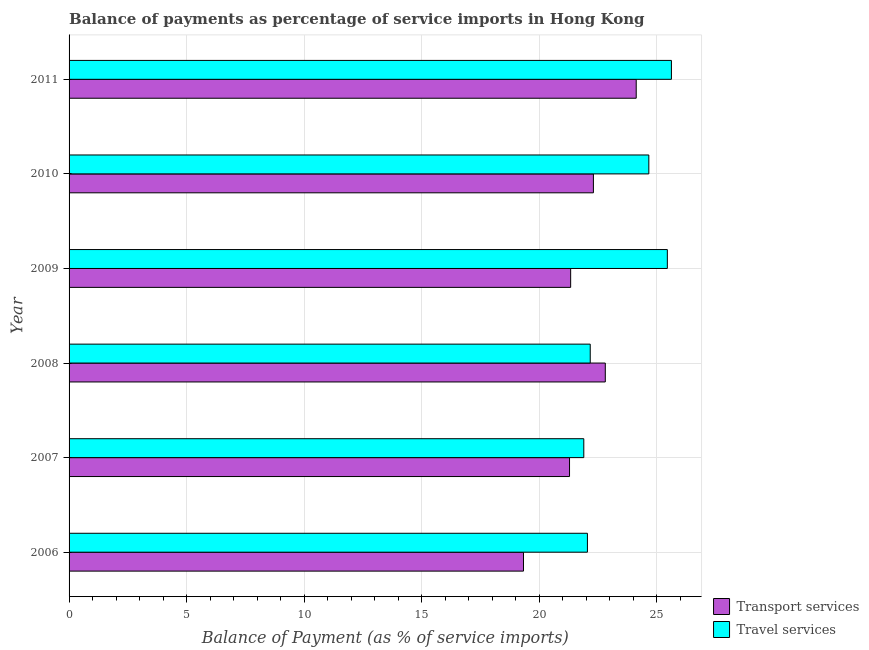How many different coloured bars are there?
Offer a very short reply. 2. Are the number of bars per tick equal to the number of legend labels?
Provide a succinct answer. Yes. Are the number of bars on each tick of the Y-axis equal?
Your answer should be very brief. Yes. In how many cases, is the number of bars for a given year not equal to the number of legend labels?
Offer a terse response. 0. What is the balance of payments of travel services in 2007?
Make the answer very short. 21.89. Across all years, what is the maximum balance of payments of travel services?
Make the answer very short. 25.62. Across all years, what is the minimum balance of payments of travel services?
Make the answer very short. 21.89. In which year was the balance of payments of transport services minimum?
Keep it short and to the point. 2006. What is the total balance of payments of travel services in the graph?
Your response must be concise. 141.81. What is the difference between the balance of payments of travel services in 2009 and that in 2010?
Your answer should be compact. 0.79. What is the difference between the balance of payments of transport services in 2009 and the balance of payments of travel services in 2006?
Your answer should be very brief. -0.71. What is the average balance of payments of travel services per year?
Offer a terse response. 23.64. In the year 2006, what is the difference between the balance of payments of travel services and balance of payments of transport services?
Offer a very short reply. 2.72. What is the ratio of the balance of payments of transport services in 2007 to that in 2011?
Your response must be concise. 0.88. Is the balance of payments of transport services in 2008 less than that in 2010?
Make the answer very short. No. Is the difference between the balance of payments of travel services in 2008 and 2009 greater than the difference between the balance of payments of transport services in 2008 and 2009?
Make the answer very short. No. What is the difference between the highest and the second highest balance of payments of transport services?
Keep it short and to the point. 1.31. What is the difference between the highest and the lowest balance of payments of travel services?
Ensure brevity in your answer.  3.73. In how many years, is the balance of payments of travel services greater than the average balance of payments of travel services taken over all years?
Offer a terse response. 3. Is the sum of the balance of payments of travel services in 2006 and 2007 greater than the maximum balance of payments of transport services across all years?
Your answer should be compact. Yes. What does the 2nd bar from the top in 2011 represents?
Offer a very short reply. Transport services. What does the 1st bar from the bottom in 2008 represents?
Give a very brief answer. Transport services. How many bars are there?
Provide a short and direct response. 12. Are all the bars in the graph horizontal?
Your response must be concise. Yes. Are the values on the major ticks of X-axis written in scientific E-notation?
Ensure brevity in your answer.  No. Does the graph contain any zero values?
Offer a terse response. No. Where does the legend appear in the graph?
Give a very brief answer. Bottom right. What is the title of the graph?
Offer a terse response. Balance of payments as percentage of service imports in Hong Kong. What is the label or title of the X-axis?
Ensure brevity in your answer.  Balance of Payment (as % of service imports). What is the Balance of Payment (as % of service imports) of Transport services in 2006?
Your answer should be very brief. 19.32. What is the Balance of Payment (as % of service imports) in Travel services in 2006?
Your answer should be compact. 22.04. What is the Balance of Payment (as % of service imports) in Transport services in 2007?
Give a very brief answer. 21.28. What is the Balance of Payment (as % of service imports) of Travel services in 2007?
Offer a terse response. 21.89. What is the Balance of Payment (as % of service imports) in Transport services in 2008?
Provide a short and direct response. 22.8. What is the Balance of Payment (as % of service imports) of Travel services in 2008?
Your response must be concise. 22.16. What is the Balance of Payment (as % of service imports) in Transport services in 2009?
Your response must be concise. 21.33. What is the Balance of Payment (as % of service imports) of Travel services in 2009?
Offer a very short reply. 25.44. What is the Balance of Payment (as % of service imports) of Transport services in 2010?
Make the answer very short. 22.3. What is the Balance of Payment (as % of service imports) of Travel services in 2010?
Offer a terse response. 24.66. What is the Balance of Payment (as % of service imports) of Transport services in 2011?
Offer a very short reply. 24.12. What is the Balance of Payment (as % of service imports) in Travel services in 2011?
Keep it short and to the point. 25.62. Across all years, what is the maximum Balance of Payment (as % of service imports) in Transport services?
Provide a short and direct response. 24.12. Across all years, what is the maximum Balance of Payment (as % of service imports) in Travel services?
Offer a very short reply. 25.62. Across all years, what is the minimum Balance of Payment (as % of service imports) in Transport services?
Your response must be concise. 19.32. Across all years, what is the minimum Balance of Payment (as % of service imports) of Travel services?
Your answer should be very brief. 21.89. What is the total Balance of Payment (as % of service imports) of Transport services in the graph?
Keep it short and to the point. 131.16. What is the total Balance of Payment (as % of service imports) in Travel services in the graph?
Your answer should be very brief. 141.81. What is the difference between the Balance of Payment (as % of service imports) in Transport services in 2006 and that in 2007?
Offer a terse response. -1.96. What is the difference between the Balance of Payment (as % of service imports) in Travel services in 2006 and that in 2007?
Your answer should be very brief. 0.15. What is the difference between the Balance of Payment (as % of service imports) in Transport services in 2006 and that in 2008?
Make the answer very short. -3.48. What is the difference between the Balance of Payment (as % of service imports) of Travel services in 2006 and that in 2008?
Ensure brevity in your answer.  -0.12. What is the difference between the Balance of Payment (as % of service imports) in Transport services in 2006 and that in 2009?
Keep it short and to the point. -2.01. What is the difference between the Balance of Payment (as % of service imports) of Travel services in 2006 and that in 2009?
Ensure brevity in your answer.  -3.4. What is the difference between the Balance of Payment (as % of service imports) in Transport services in 2006 and that in 2010?
Offer a terse response. -2.97. What is the difference between the Balance of Payment (as % of service imports) in Travel services in 2006 and that in 2010?
Keep it short and to the point. -2.61. What is the difference between the Balance of Payment (as % of service imports) in Transport services in 2006 and that in 2011?
Offer a terse response. -4.79. What is the difference between the Balance of Payment (as % of service imports) in Travel services in 2006 and that in 2011?
Your answer should be compact. -3.57. What is the difference between the Balance of Payment (as % of service imports) of Transport services in 2007 and that in 2008?
Ensure brevity in your answer.  -1.52. What is the difference between the Balance of Payment (as % of service imports) of Travel services in 2007 and that in 2008?
Your response must be concise. -0.27. What is the difference between the Balance of Payment (as % of service imports) in Transport services in 2007 and that in 2009?
Offer a very short reply. -0.05. What is the difference between the Balance of Payment (as % of service imports) of Travel services in 2007 and that in 2009?
Your answer should be very brief. -3.55. What is the difference between the Balance of Payment (as % of service imports) of Transport services in 2007 and that in 2010?
Give a very brief answer. -1.02. What is the difference between the Balance of Payment (as % of service imports) in Travel services in 2007 and that in 2010?
Keep it short and to the point. -2.77. What is the difference between the Balance of Payment (as % of service imports) in Transport services in 2007 and that in 2011?
Offer a terse response. -2.84. What is the difference between the Balance of Payment (as % of service imports) in Travel services in 2007 and that in 2011?
Make the answer very short. -3.73. What is the difference between the Balance of Payment (as % of service imports) of Transport services in 2008 and that in 2009?
Your answer should be compact. 1.47. What is the difference between the Balance of Payment (as % of service imports) in Travel services in 2008 and that in 2009?
Offer a terse response. -3.28. What is the difference between the Balance of Payment (as % of service imports) of Transport services in 2008 and that in 2010?
Your answer should be very brief. 0.51. What is the difference between the Balance of Payment (as % of service imports) in Travel services in 2008 and that in 2010?
Offer a very short reply. -2.49. What is the difference between the Balance of Payment (as % of service imports) in Transport services in 2008 and that in 2011?
Offer a very short reply. -1.31. What is the difference between the Balance of Payment (as % of service imports) of Travel services in 2008 and that in 2011?
Your answer should be very brief. -3.45. What is the difference between the Balance of Payment (as % of service imports) in Transport services in 2009 and that in 2010?
Provide a succinct answer. -0.97. What is the difference between the Balance of Payment (as % of service imports) of Travel services in 2009 and that in 2010?
Your answer should be very brief. 0.79. What is the difference between the Balance of Payment (as % of service imports) in Transport services in 2009 and that in 2011?
Your response must be concise. -2.79. What is the difference between the Balance of Payment (as % of service imports) of Travel services in 2009 and that in 2011?
Your answer should be very brief. -0.17. What is the difference between the Balance of Payment (as % of service imports) in Transport services in 2010 and that in 2011?
Provide a short and direct response. -1.82. What is the difference between the Balance of Payment (as % of service imports) in Travel services in 2010 and that in 2011?
Make the answer very short. -0.96. What is the difference between the Balance of Payment (as % of service imports) of Transport services in 2006 and the Balance of Payment (as % of service imports) of Travel services in 2007?
Your response must be concise. -2.56. What is the difference between the Balance of Payment (as % of service imports) of Transport services in 2006 and the Balance of Payment (as % of service imports) of Travel services in 2008?
Ensure brevity in your answer.  -2.84. What is the difference between the Balance of Payment (as % of service imports) of Transport services in 2006 and the Balance of Payment (as % of service imports) of Travel services in 2009?
Your answer should be very brief. -6.12. What is the difference between the Balance of Payment (as % of service imports) of Transport services in 2006 and the Balance of Payment (as % of service imports) of Travel services in 2010?
Offer a terse response. -5.33. What is the difference between the Balance of Payment (as % of service imports) in Transport services in 2006 and the Balance of Payment (as % of service imports) in Travel services in 2011?
Your response must be concise. -6.29. What is the difference between the Balance of Payment (as % of service imports) in Transport services in 2007 and the Balance of Payment (as % of service imports) in Travel services in 2008?
Provide a short and direct response. -0.88. What is the difference between the Balance of Payment (as % of service imports) of Transport services in 2007 and the Balance of Payment (as % of service imports) of Travel services in 2009?
Your answer should be very brief. -4.16. What is the difference between the Balance of Payment (as % of service imports) of Transport services in 2007 and the Balance of Payment (as % of service imports) of Travel services in 2010?
Give a very brief answer. -3.37. What is the difference between the Balance of Payment (as % of service imports) of Transport services in 2007 and the Balance of Payment (as % of service imports) of Travel services in 2011?
Provide a succinct answer. -4.33. What is the difference between the Balance of Payment (as % of service imports) in Transport services in 2008 and the Balance of Payment (as % of service imports) in Travel services in 2009?
Keep it short and to the point. -2.64. What is the difference between the Balance of Payment (as % of service imports) in Transport services in 2008 and the Balance of Payment (as % of service imports) in Travel services in 2010?
Give a very brief answer. -1.85. What is the difference between the Balance of Payment (as % of service imports) of Transport services in 2008 and the Balance of Payment (as % of service imports) of Travel services in 2011?
Offer a terse response. -2.81. What is the difference between the Balance of Payment (as % of service imports) of Transport services in 2009 and the Balance of Payment (as % of service imports) of Travel services in 2010?
Provide a succinct answer. -3.32. What is the difference between the Balance of Payment (as % of service imports) in Transport services in 2009 and the Balance of Payment (as % of service imports) in Travel services in 2011?
Make the answer very short. -4.29. What is the difference between the Balance of Payment (as % of service imports) of Transport services in 2010 and the Balance of Payment (as % of service imports) of Travel services in 2011?
Offer a very short reply. -3.32. What is the average Balance of Payment (as % of service imports) of Transport services per year?
Keep it short and to the point. 21.86. What is the average Balance of Payment (as % of service imports) in Travel services per year?
Your answer should be compact. 23.64. In the year 2006, what is the difference between the Balance of Payment (as % of service imports) in Transport services and Balance of Payment (as % of service imports) in Travel services?
Give a very brief answer. -2.72. In the year 2007, what is the difference between the Balance of Payment (as % of service imports) of Transport services and Balance of Payment (as % of service imports) of Travel services?
Keep it short and to the point. -0.61. In the year 2008, what is the difference between the Balance of Payment (as % of service imports) in Transport services and Balance of Payment (as % of service imports) in Travel services?
Provide a short and direct response. 0.64. In the year 2009, what is the difference between the Balance of Payment (as % of service imports) of Transport services and Balance of Payment (as % of service imports) of Travel services?
Give a very brief answer. -4.11. In the year 2010, what is the difference between the Balance of Payment (as % of service imports) in Transport services and Balance of Payment (as % of service imports) in Travel services?
Provide a succinct answer. -2.36. In the year 2011, what is the difference between the Balance of Payment (as % of service imports) in Transport services and Balance of Payment (as % of service imports) in Travel services?
Give a very brief answer. -1.5. What is the ratio of the Balance of Payment (as % of service imports) in Transport services in 2006 to that in 2007?
Your answer should be very brief. 0.91. What is the ratio of the Balance of Payment (as % of service imports) of Transport services in 2006 to that in 2008?
Give a very brief answer. 0.85. What is the ratio of the Balance of Payment (as % of service imports) of Transport services in 2006 to that in 2009?
Your answer should be very brief. 0.91. What is the ratio of the Balance of Payment (as % of service imports) of Travel services in 2006 to that in 2009?
Keep it short and to the point. 0.87. What is the ratio of the Balance of Payment (as % of service imports) in Transport services in 2006 to that in 2010?
Make the answer very short. 0.87. What is the ratio of the Balance of Payment (as % of service imports) of Travel services in 2006 to that in 2010?
Make the answer very short. 0.89. What is the ratio of the Balance of Payment (as % of service imports) of Transport services in 2006 to that in 2011?
Ensure brevity in your answer.  0.8. What is the ratio of the Balance of Payment (as % of service imports) in Travel services in 2006 to that in 2011?
Provide a short and direct response. 0.86. What is the ratio of the Balance of Payment (as % of service imports) in Transport services in 2007 to that in 2008?
Offer a terse response. 0.93. What is the ratio of the Balance of Payment (as % of service imports) in Travel services in 2007 to that in 2008?
Give a very brief answer. 0.99. What is the ratio of the Balance of Payment (as % of service imports) in Transport services in 2007 to that in 2009?
Keep it short and to the point. 1. What is the ratio of the Balance of Payment (as % of service imports) in Travel services in 2007 to that in 2009?
Your answer should be compact. 0.86. What is the ratio of the Balance of Payment (as % of service imports) in Transport services in 2007 to that in 2010?
Offer a very short reply. 0.95. What is the ratio of the Balance of Payment (as % of service imports) of Travel services in 2007 to that in 2010?
Offer a very short reply. 0.89. What is the ratio of the Balance of Payment (as % of service imports) of Transport services in 2007 to that in 2011?
Your answer should be compact. 0.88. What is the ratio of the Balance of Payment (as % of service imports) in Travel services in 2007 to that in 2011?
Keep it short and to the point. 0.85. What is the ratio of the Balance of Payment (as % of service imports) in Transport services in 2008 to that in 2009?
Provide a succinct answer. 1.07. What is the ratio of the Balance of Payment (as % of service imports) in Travel services in 2008 to that in 2009?
Your answer should be very brief. 0.87. What is the ratio of the Balance of Payment (as % of service imports) of Transport services in 2008 to that in 2010?
Give a very brief answer. 1.02. What is the ratio of the Balance of Payment (as % of service imports) in Travel services in 2008 to that in 2010?
Your answer should be compact. 0.9. What is the ratio of the Balance of Payment (as % of service imports) of Transport services in 2008 to that in 2011?
Your answer should be very brief. 0.95. What is the ratio of the Balance of Payment (as % of service imports) in Travel services in 2008 to that in 2011?
Ensure brevity in your answer.  0.87. What is the ratio of the Balance of Payment (as % of service imports) in Transport services in 2009 to that in 2010?
Provide a succinct answer. 0.96. What is the ratio of the Balance of Payment (as % of service imports) of Travel services in 2009 to that in 2010?
Keep it short and to the point. 1.03. What is the ratio of the Balance of Payment (as % of service imports) of Transport services in 2009 to that in 2011?
Keep it short and to the point. 0.88. What is the ratio of the Balance of Payment (as % of service imports) of Transport services in 2010 to that in 2011?
Provide a short and direct response. 0.92. What is the ratio of the Balance of Payment (as % of service imports) in Travel services in 2010 to that in 2011?
Provide a succinct answer. 0.96. What is the difference between the highest and the second highest Balance of Payment (as % of service imports) of Transport services?
Keep it short and to the point. 1.31. What is the difference between the highest and the second highest Balance of Payment (as % of service imports) of Travel services?
Give a very brief answer. 0.17. What is the difference between the highest and the lowest Balance of Payment (as % of service imports) of Transport services?
Provide a succinct answer. 4.79. What is the difference between the highest and the lowest Balance of Payment (as % of service imports) in Travel services?
Offer a terse response. 3.73. 